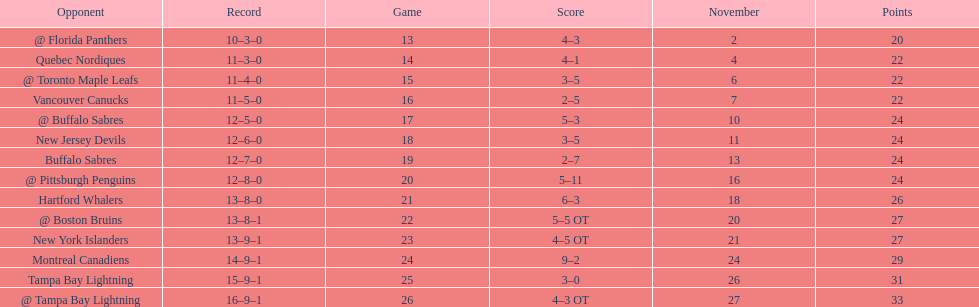Were the new jersey devils in last place according to the chart? No. 